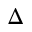<formula> <loc_0><loc_0><loc_500><loc_500>\Delta</formula> 